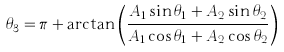Convert formula to latex. <formula><loc_0><loc_0><loc_500><loc_500>\theta _ { 3 } = \pi + \arctan \left ( { \frac { A _ { 1 } \sin \theta _ { 1 } + A _ { 2 } \sin \theta _ { 2 } } { A _ { 1 } \cos \theta _ { 1 } + A _ { 2 } \cos \theta _ { 2 } } } \right )</formula> 